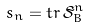Convert formula to latex. <formula><loc_0><loc_0><loc_500><loc_500>s _ { n } = t r \, { \tilde { \mathcal { S } } _ { B } } ^ { n }</formula> 